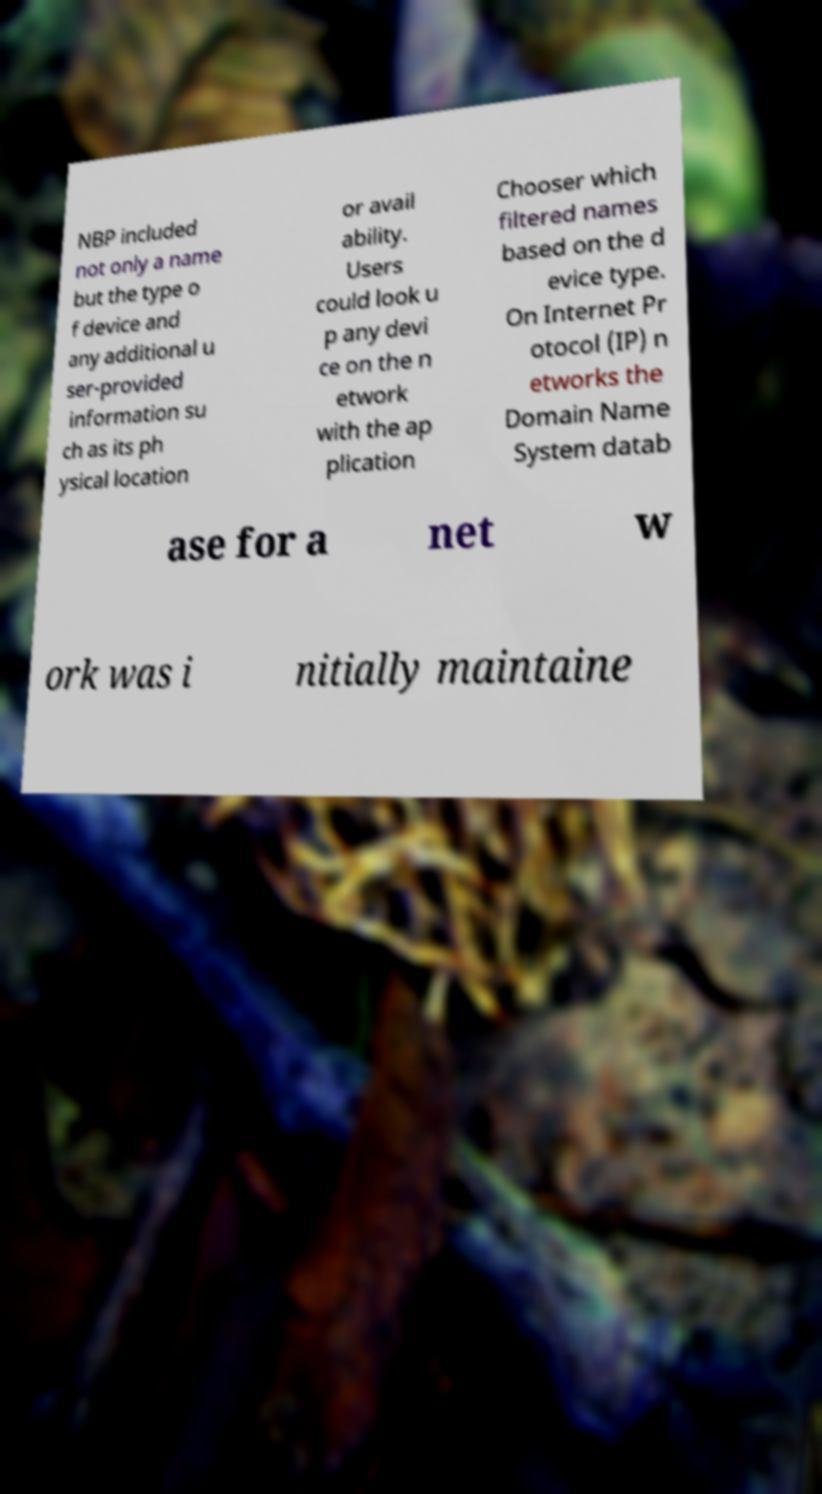What messages or text are displayed in this image? I need them in a readable, typed format. NBP included not only a name but the type o f device and any additional u ser-provided information su ch as its ph ysical location or avail ability. Users could look u p any devi ce on the n etwork with the ap plication Chooser which filtered names based on the d evice type. On Internet Pr otocol (IP) n etworks the Domain Name System datab ase for a net w ork was i nitially maintaine 